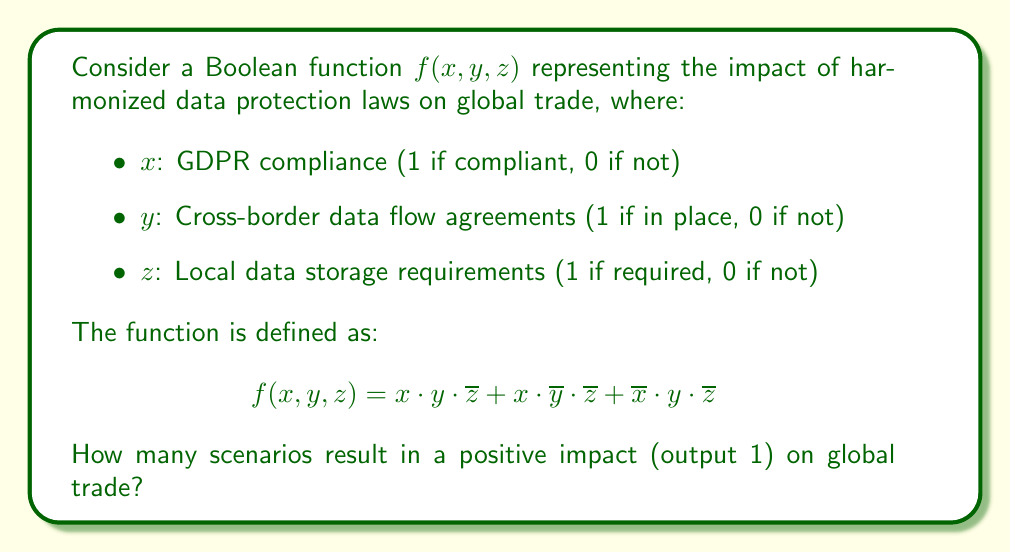Can you solve this math problem? To solve this problem, we need to analyze the Boolean function and count the number of input combinations that result in an output of 1. Let's break it down step-by-step:

1) First, let's simplify the function:
   $$f(x, y, z) = x \cdot y \cdot \overline{z} + x \cdot \overline{y} \cdot \overline{z} + \overline{x} \cdot y \cdot \overline{z}$$
   
   We can factor out $\overline{z}$:
   $$f(x, y, z) = \overline{z} \cdot (x \cdot y + x \cdot \overline{y} + \overline{x} \cdot y)$$

2) Now, let's consider when this function will output 1:
   - $z$ must be 0 (because of $\overline{z}$)
   - And either:
     - $x$ and $y$ are both 1, or
     - $x$ is 1 and $y$ is 0, or
     - $x$ is 0 and $y$ is 1

3) We can list these scenarios:
   - (1, 1, 0)
   - (1, 0, 0)
   - (0, 1, 0)

4) Count the number of scenarios: There are 3 scenarios that result in a positive impact on global trade.

This analysis shows that harmonized data protection laws have a positive impact when:
- There's GDPR compliance and cross-border agreements, without local storage requirements
- There's GDPR compliance, even without cross-border agreements, as long as there are no local storage requirements
- There are cross-border agreements, even without GDPR compliance, as long as there are no local storage requirements

The key factor seems to be the absence of local storage requirements, which aligns with the goal of facilitating international data transfers.
Answer: 3 